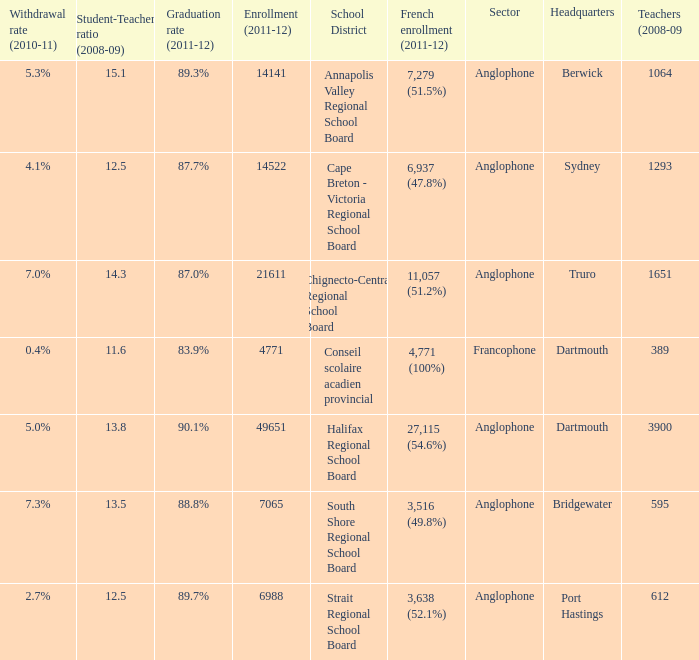What is their withdrawal rate for the school district with headquarters located in Truro? 7.0%. 